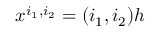<formula> <loc_0><loc_0><loc_500><loc_500>x ^ { i _ { 1 } , i _ { 2 } } = ( i _ { 1 } , i _ { 2 } ) h</formula> 